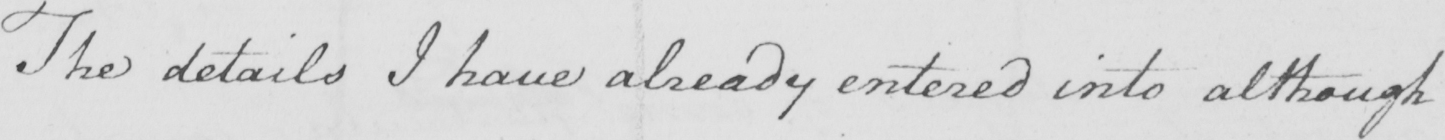What does this handwritten line say? The details I have already entered into although 